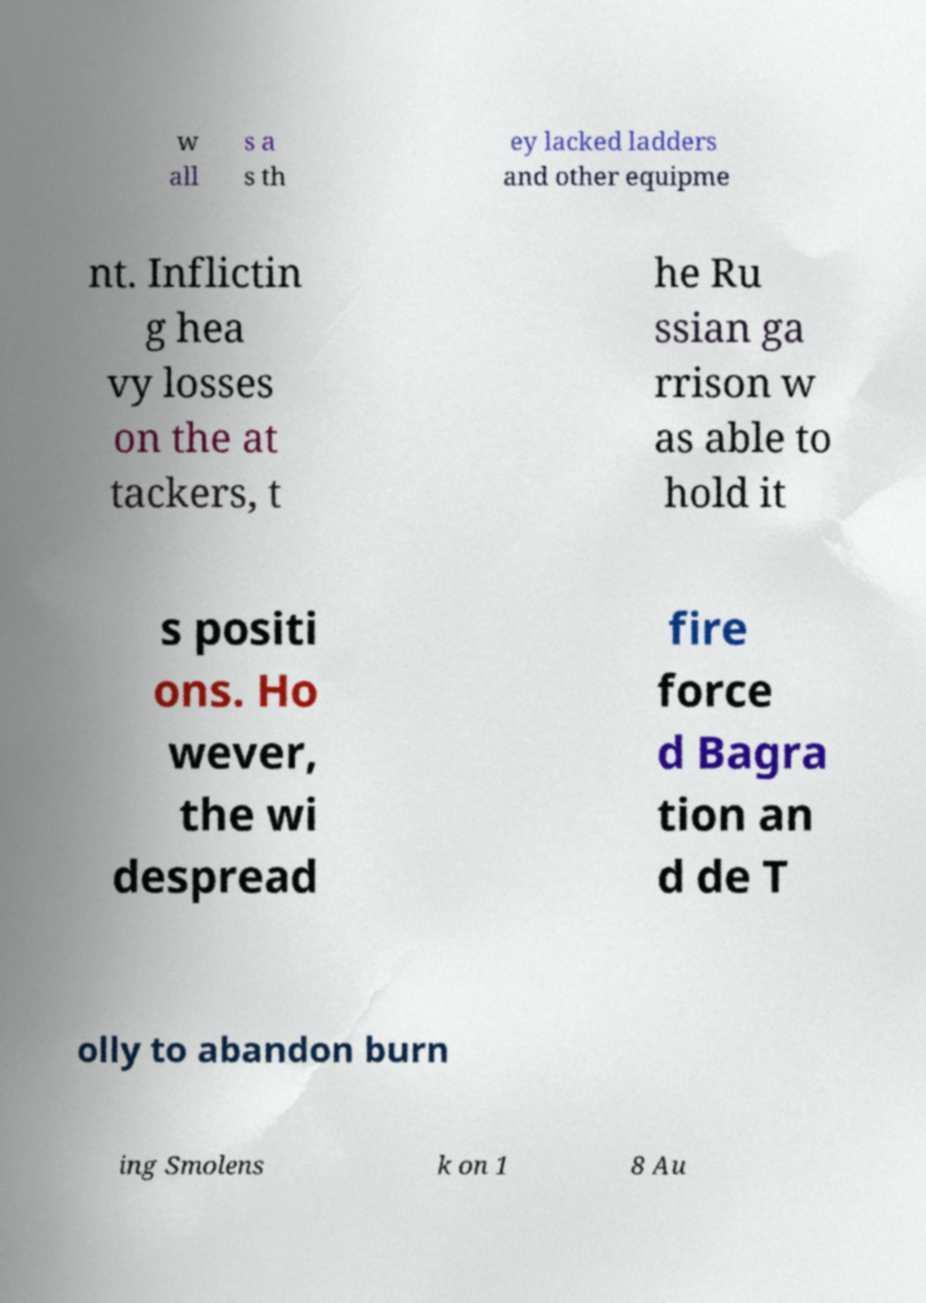For documentation purposes, I need the text within this image transcribed. Could you provide that? w all s a s th ey lacked ladders and other equipme nt. Inflictin g hea vy losses on the at tackers, t he Ru ssian ga rrison w as able to hold it s positi ons. Ho wever, the wi despread fire force d Bagra tion an d de T olly to abandon burn ing Smolens k on 1 8 Au 